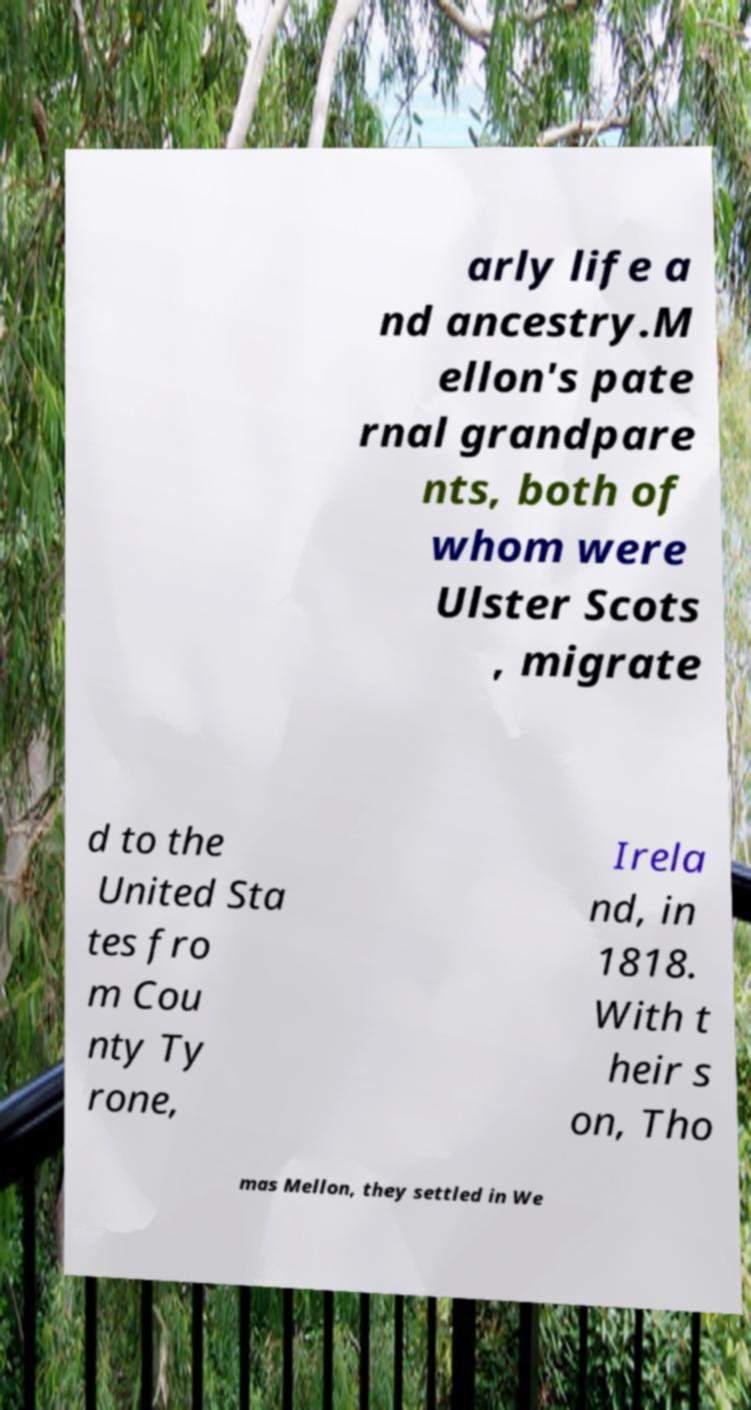There's text embedded in this image that I need extracted. Can you transcribe it verbatim? arly life a nd ancestry.M ellon's pate rnal grandpare nts, both of whom were Ulster Scots , migrate d to the United Sta tes fro m Cou nty Ty rone, Irela nd, in 1818. With t heir s on, Tho mas Mellon, they settled in We 